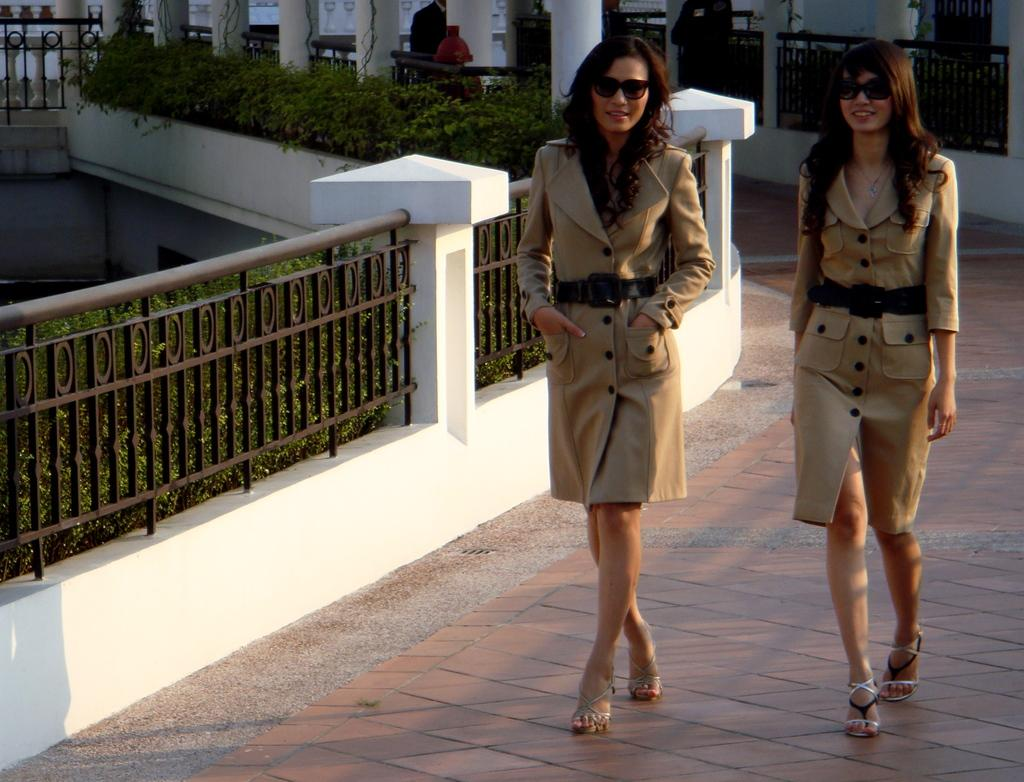What are the two ladies in the image doing? The two ladies in the image are walking. What can be seen on the left side of the image? There is a fence on the left side of the image. What type of vegetation is visible in the image? Shrubs are visible in the image. What architectural features can be seen in the background of the image? There are pillars in the background of the image. What type of fish can be seen swimming near the ladies in the image? There are no fish present in the image; it features two ladies walking and a fence, shrubs, and pillars in the background. 